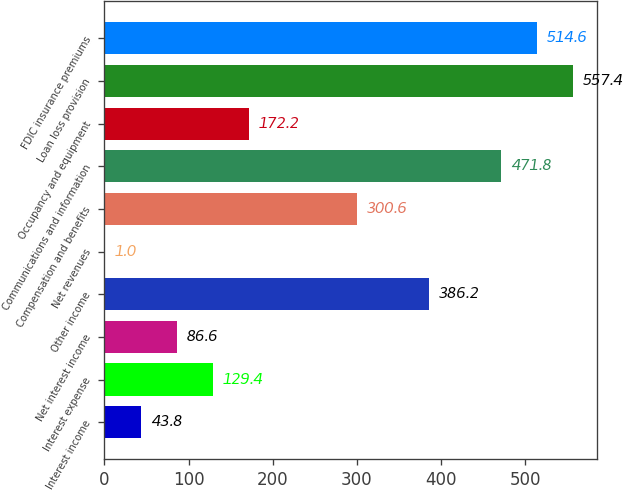Convert chart. <chart><loc_0><loc_0><loc_500><loc_500><bar_chart><fcel>Interest income<fcel>Interest expense<fcel>Net interest income<fcel>Other income<fcel>Net revenues<fcel>Compensation and benefits<fcel>Communications and information<fcel>Occupancy and equipment<fcel>Loan loss provision<fcel>FDIC insurance premiums<nl><fcel>43.8<fcel>129.4<fcel>86.6<fcel>386.2<fcel>1<fcel>300.6<fcel>471.8<fcel>172.2<fcel>557.4<fcel>514.6<nl></chart> 